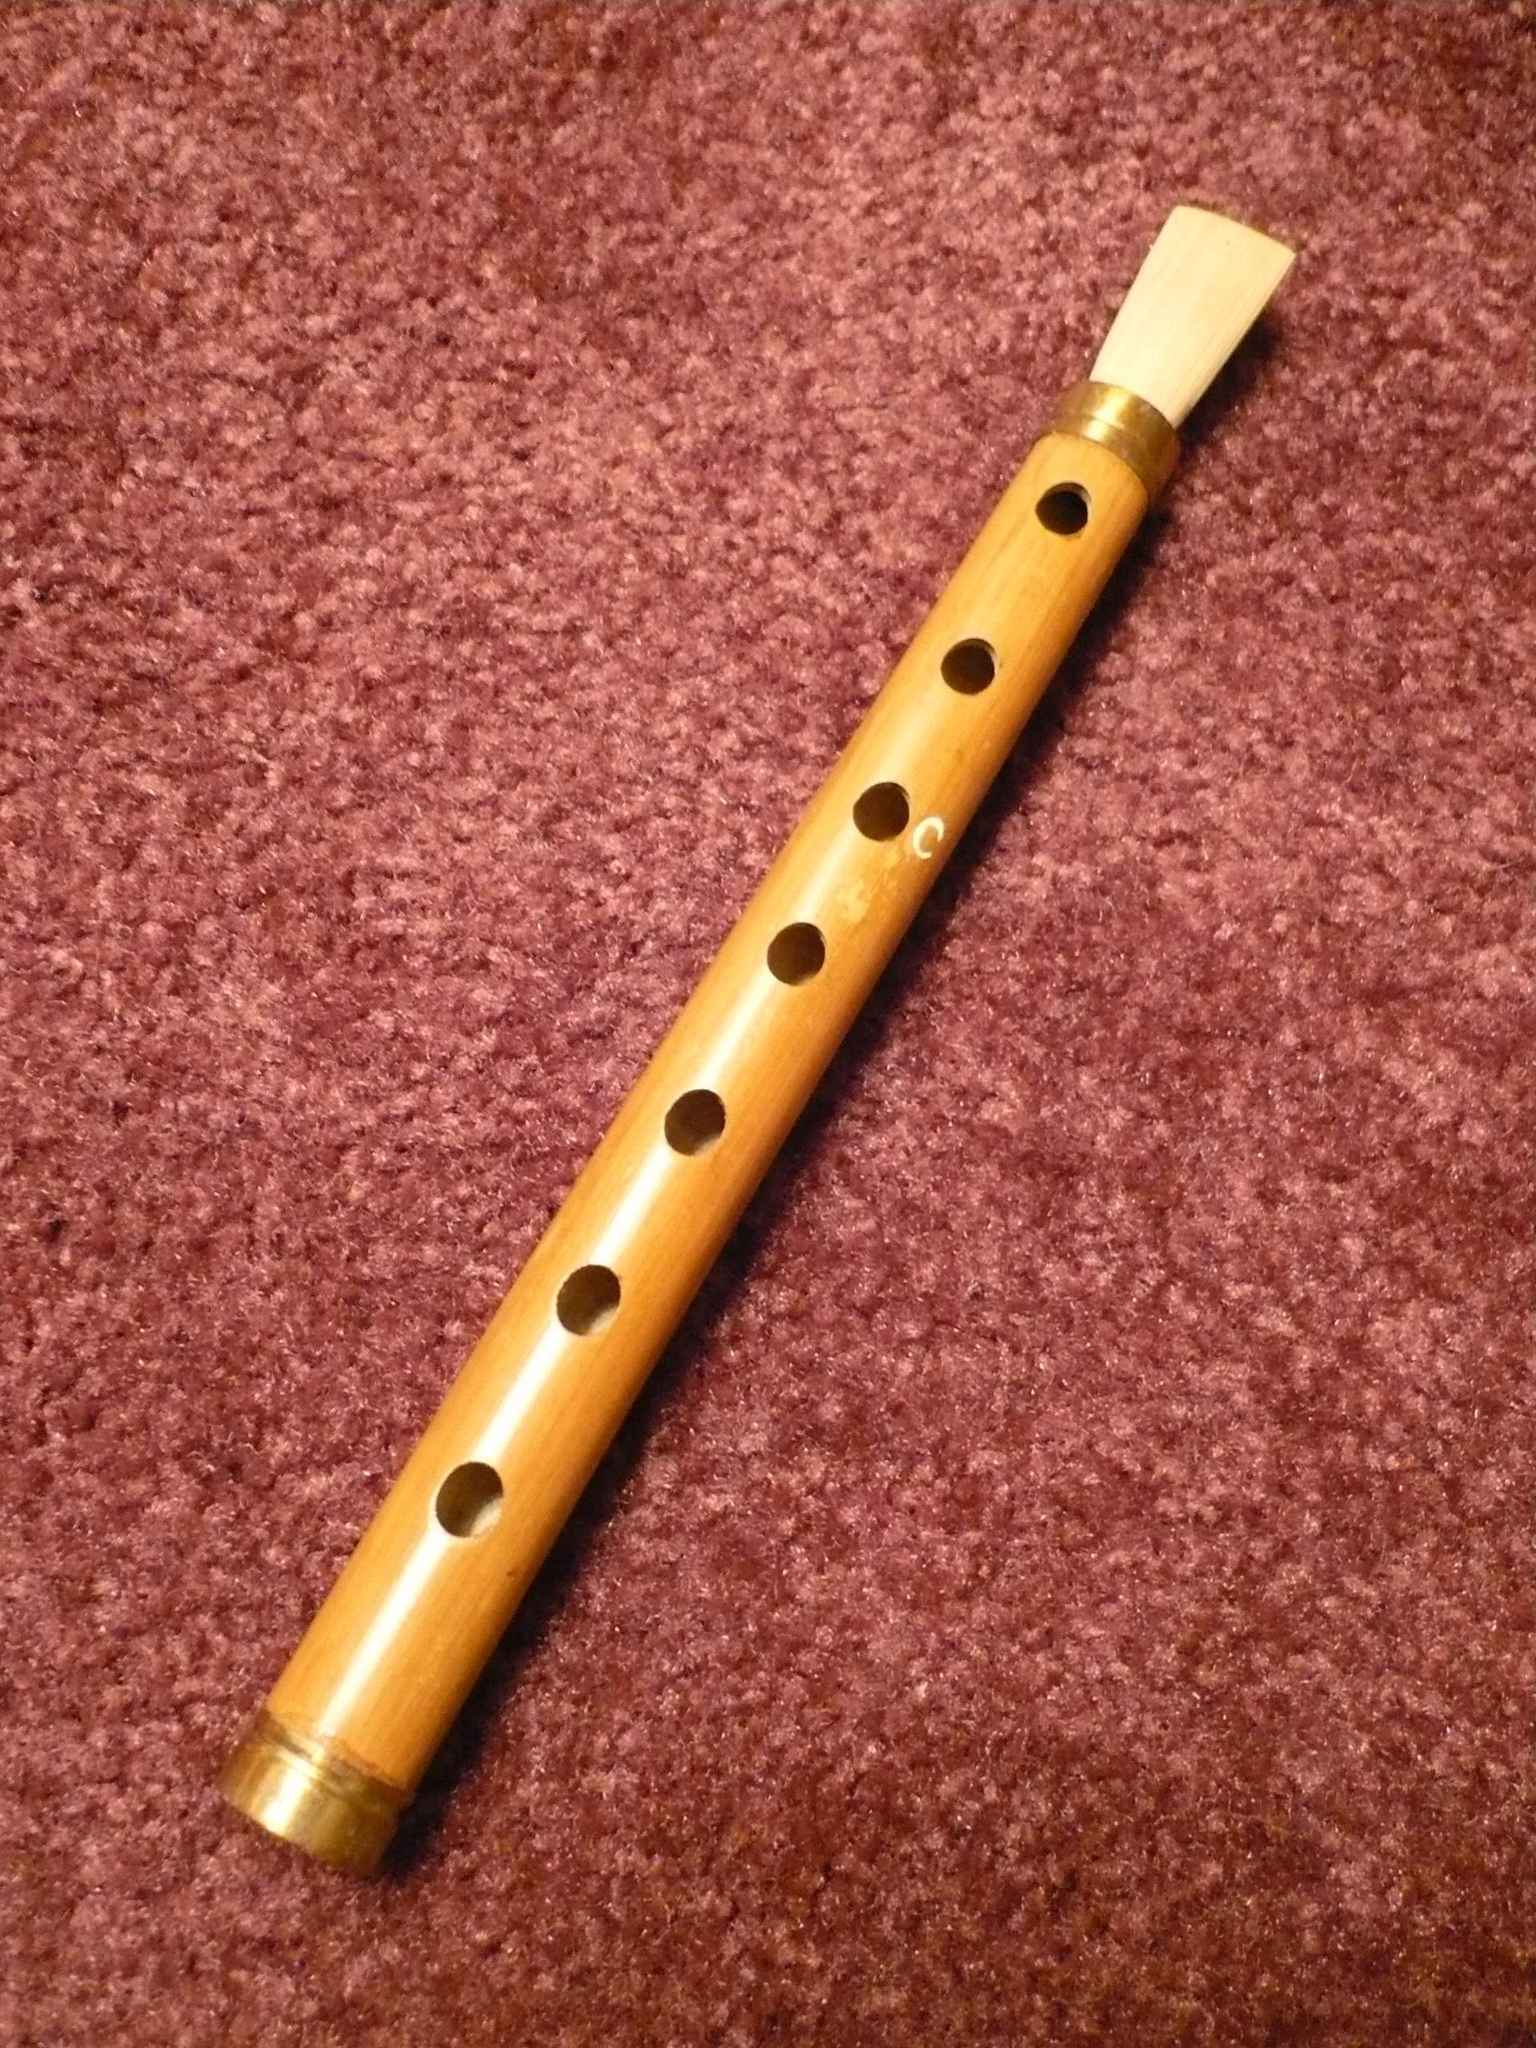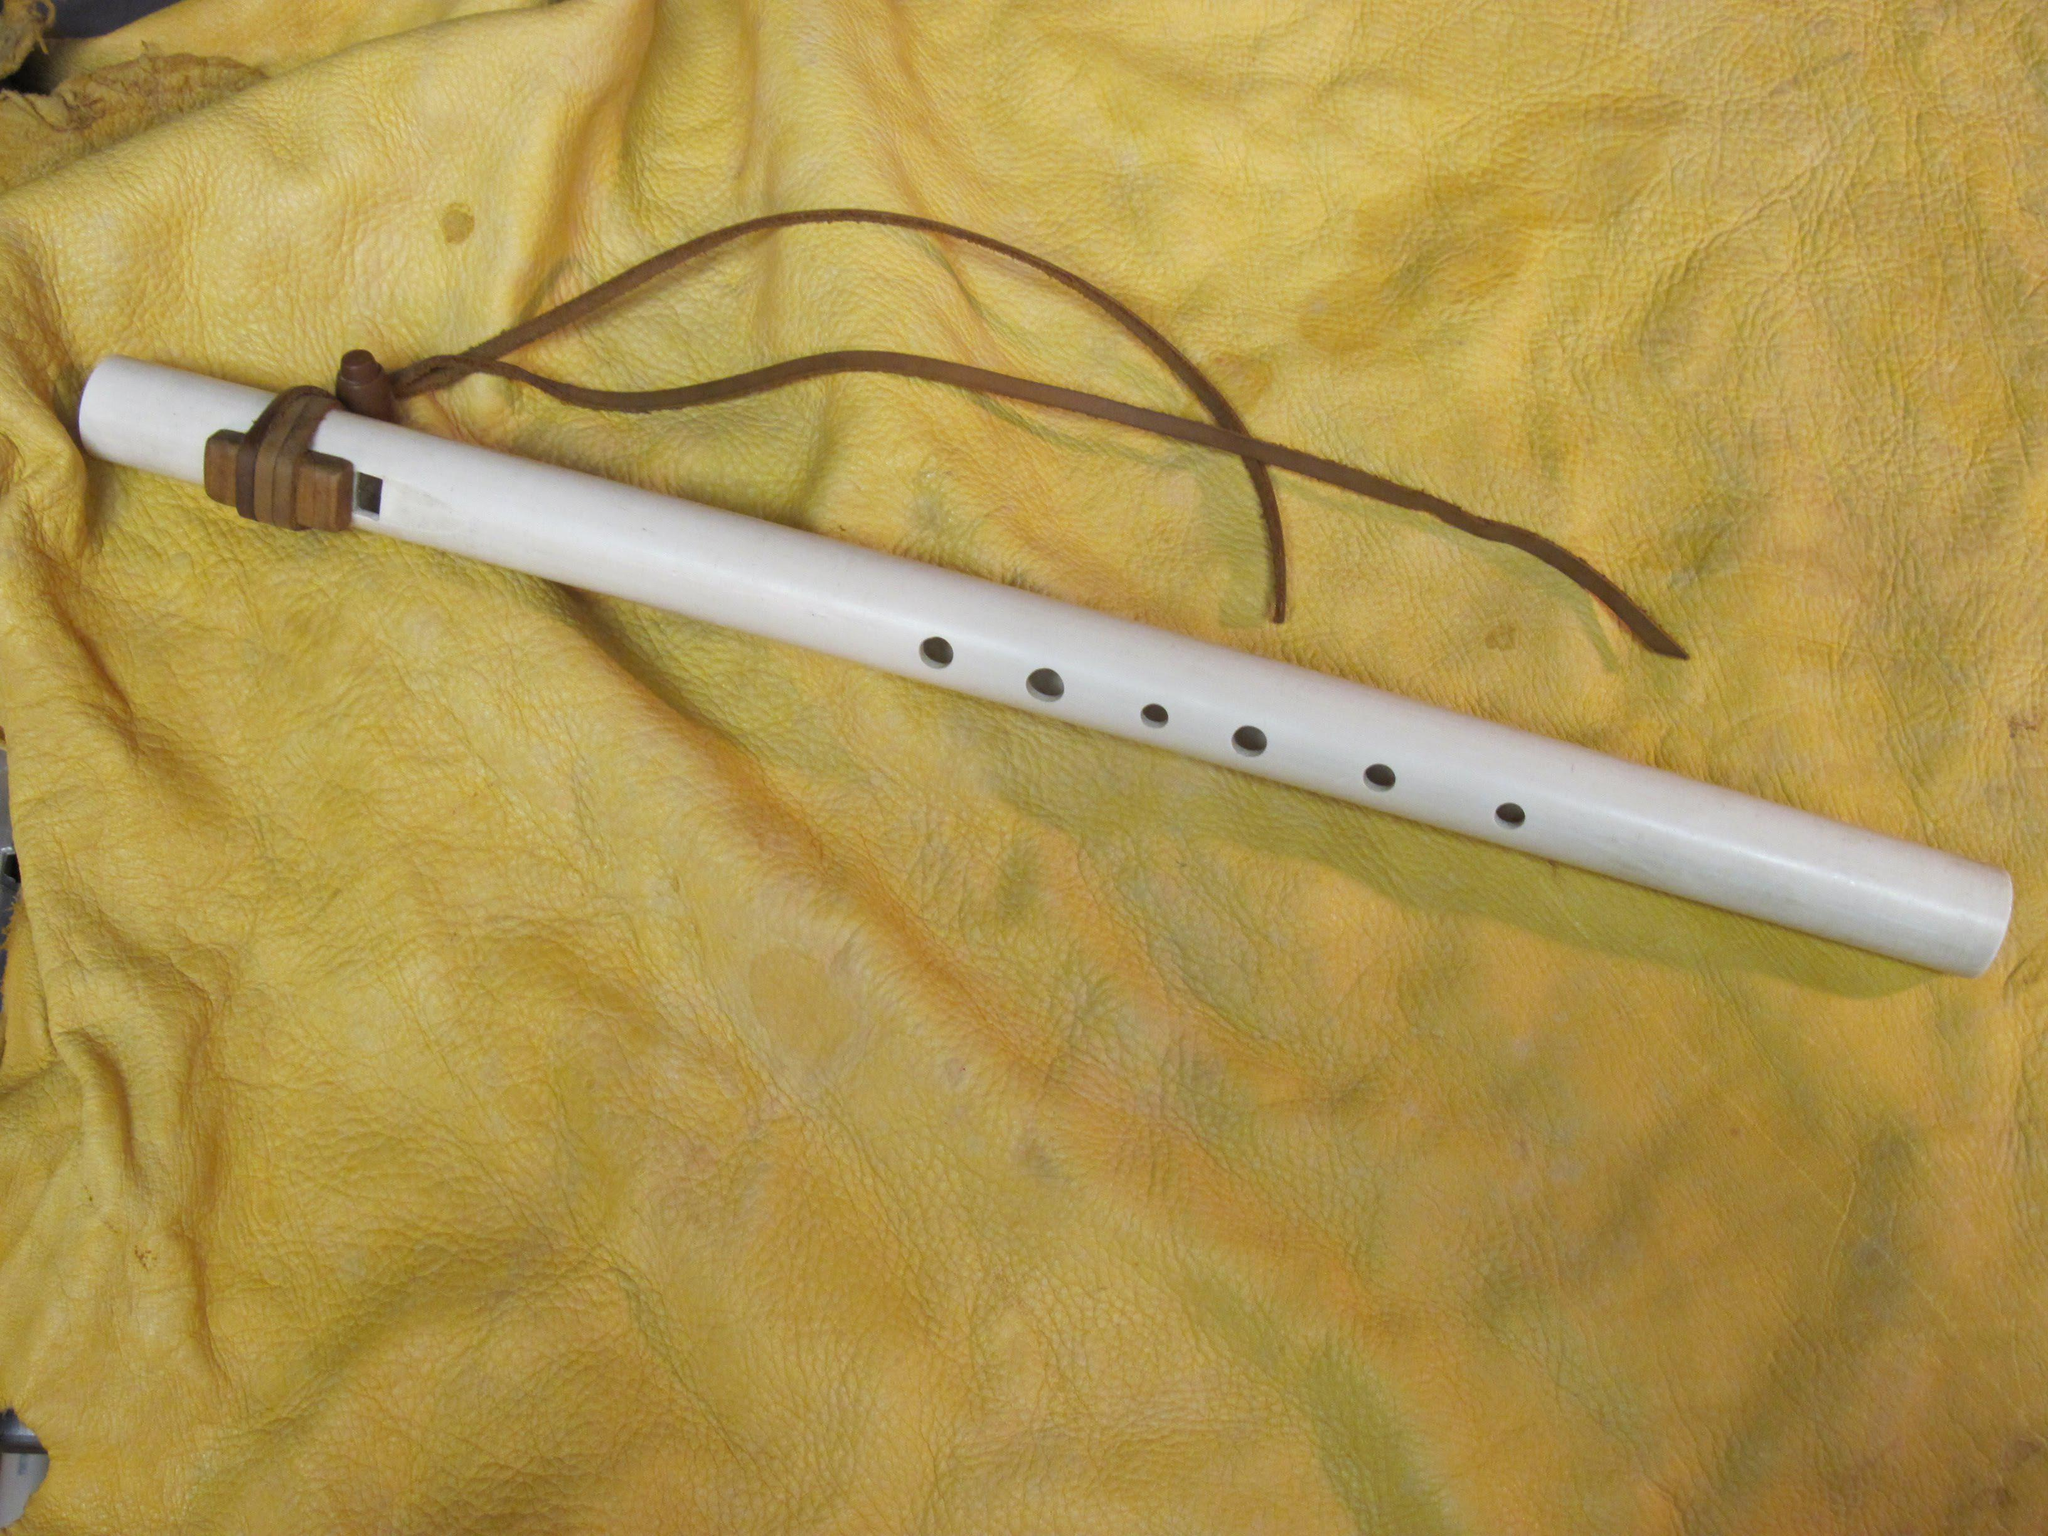The first image is the image on the left, the second image is the image on the right. Evaluate the accuracy of this statement regarding the images: "there are two flutes in the image pair". Is it true? Answer yes or no. Yes. The first image is the image on the left, the second image is the image on the right. Given the left and right images, does the statement "Each image contains one perforated, stick-like instrument displayed at an angle, and the right image shows an instrument with a leather tie on one end." hold true? Answer yes or no. Yes. 